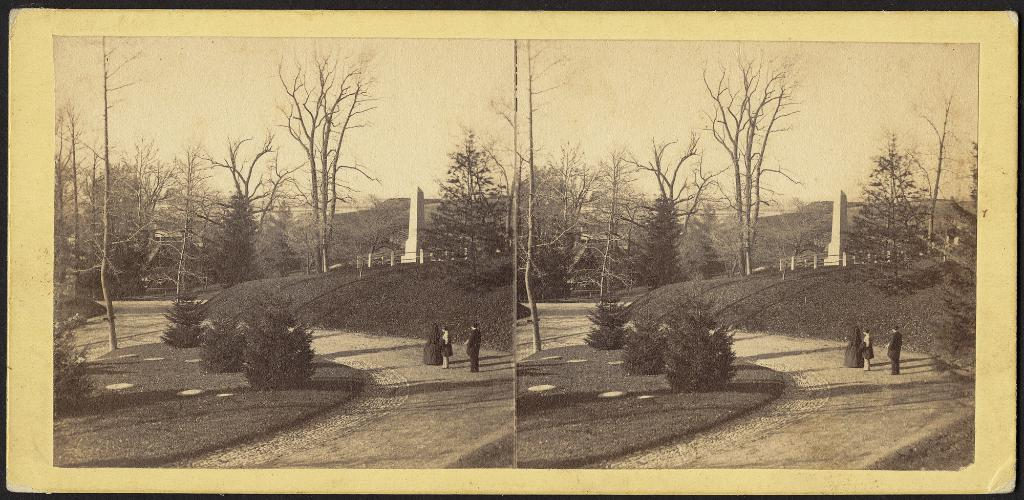What type of natural elements can be seen in the image? There are trees in the image. What else is present in the image besides trees? There are people and poles in the image. Can you describe the structure in the image? There is a pillar in the image. What type of creature can be seen interacting with the pillar in the image? There is no creature present in the image; only people, trees, poles, and a pillar are visible. 